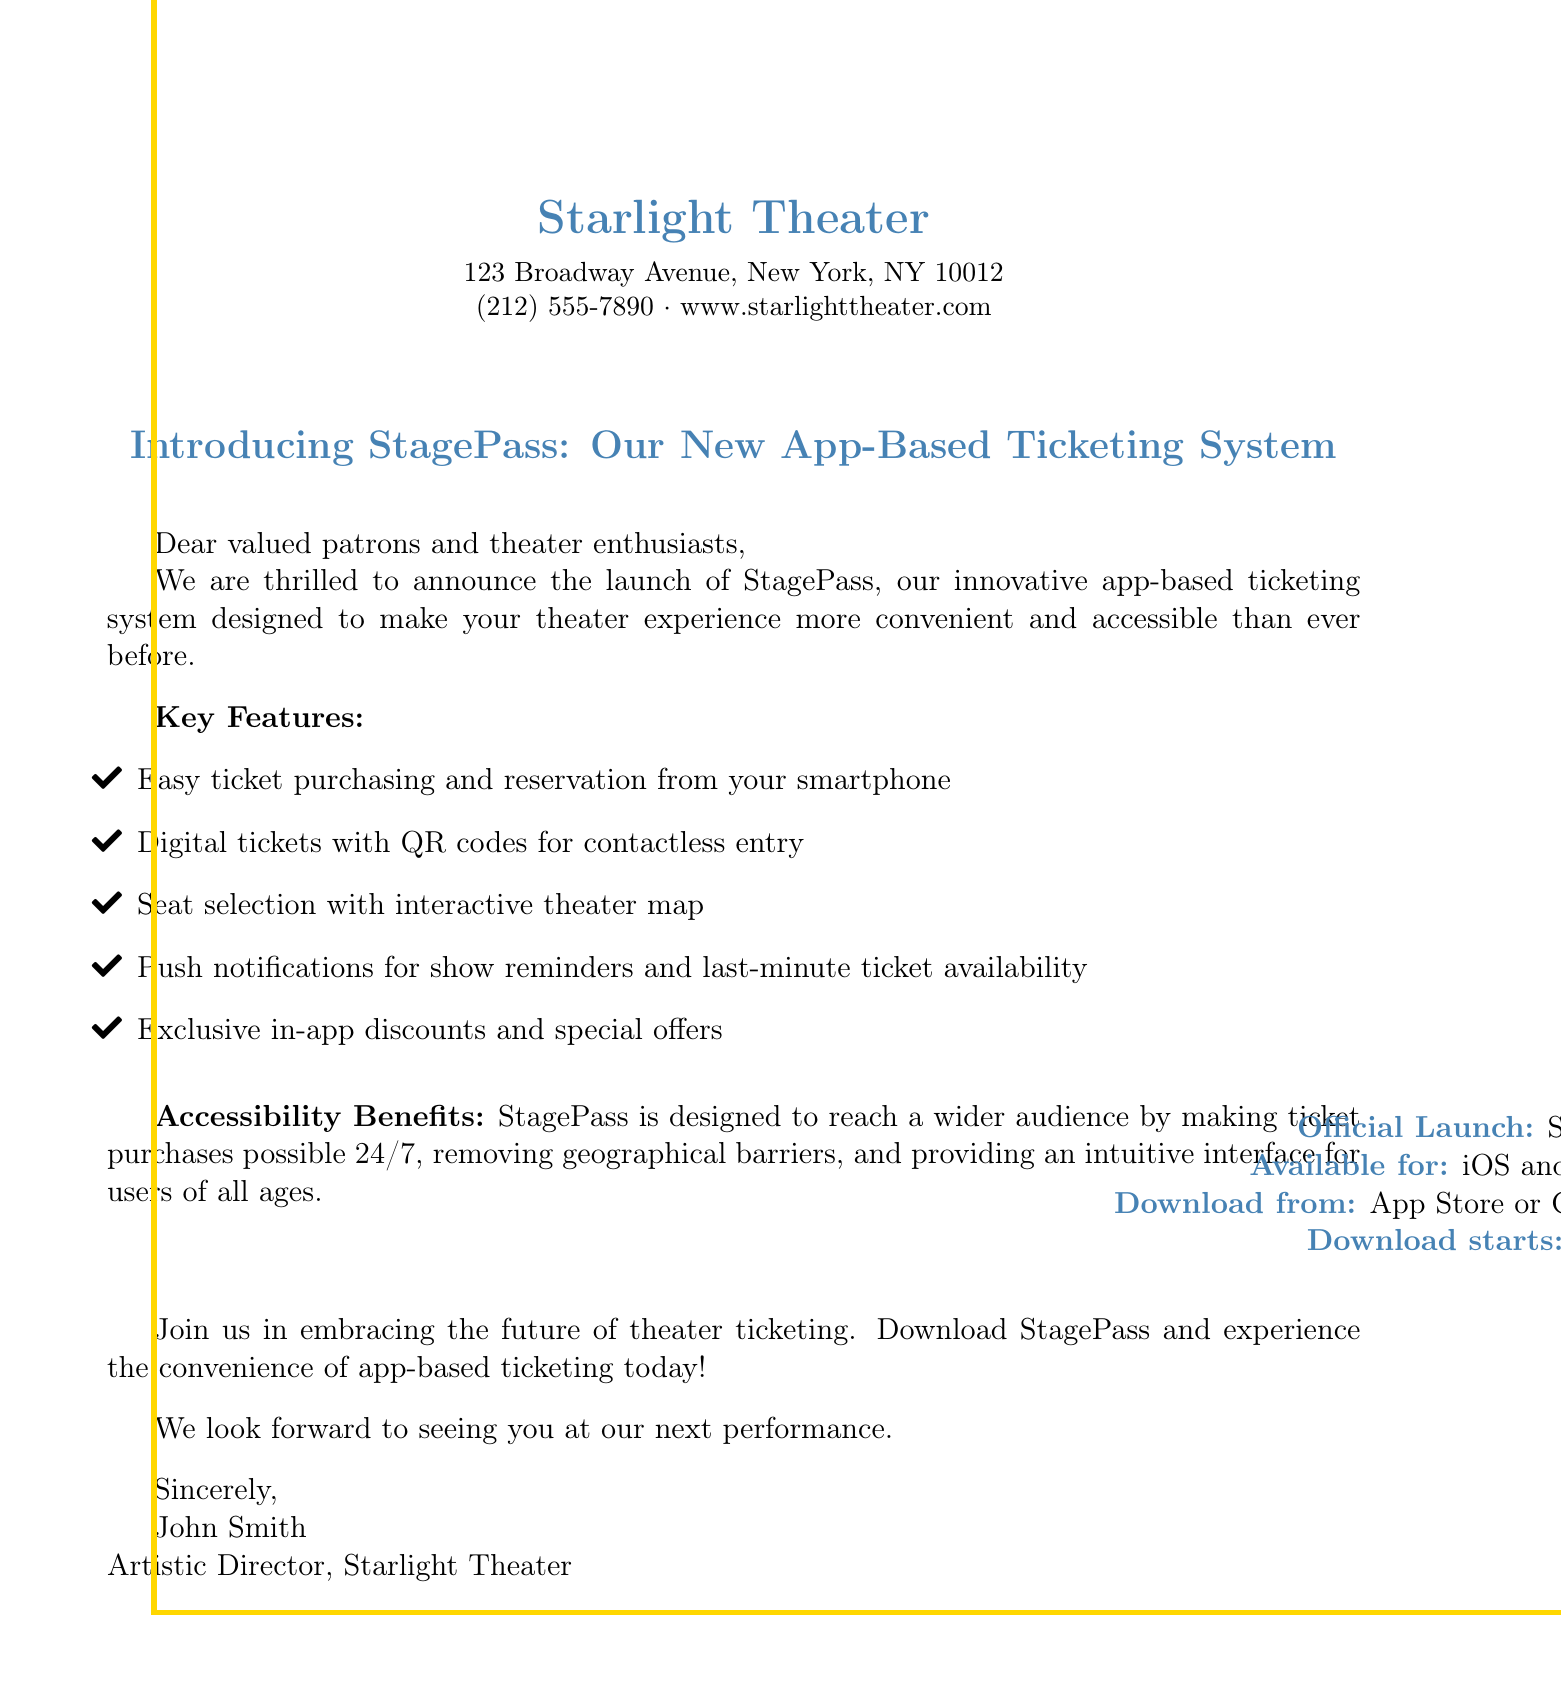What is the name of the new app-based ticketing system? The document introduces a new app-based ticketing system named StagePass.
Answer: StagePass When will the official launch date be? The document states that the official launch date is September 1, 2023.
Answer: September 1, 2023 Which platforms is StagePass available on? The document specifies that StagePass is available for iOS and Android devices.
Answer: iOS and Android What feature allows for contactless entry? The document highlights the use of digital tickets with QR codes for contactless entry.
Answer: QR codes What is one benefit of the StagePass app for accessibility? The document mentions that StagePass allows for ticket purchases 24/7, which helps reach a wider audience.
Answer: 24/7 ticket purchases When does downloading for StagePass start? According to the document, downloading for StagePass starts on August 15, 2023.
Answer: August 15, 2023 What unique discounts does StagePass offer? The document states that users can benefit from exclusive in-app discounts and special offers.
Answer: In-app discounts Who is the Artistic Director of Starlight Theater? The document is signed by John Smith, who is identified as the Artistic Director.
Answer: John Smith 